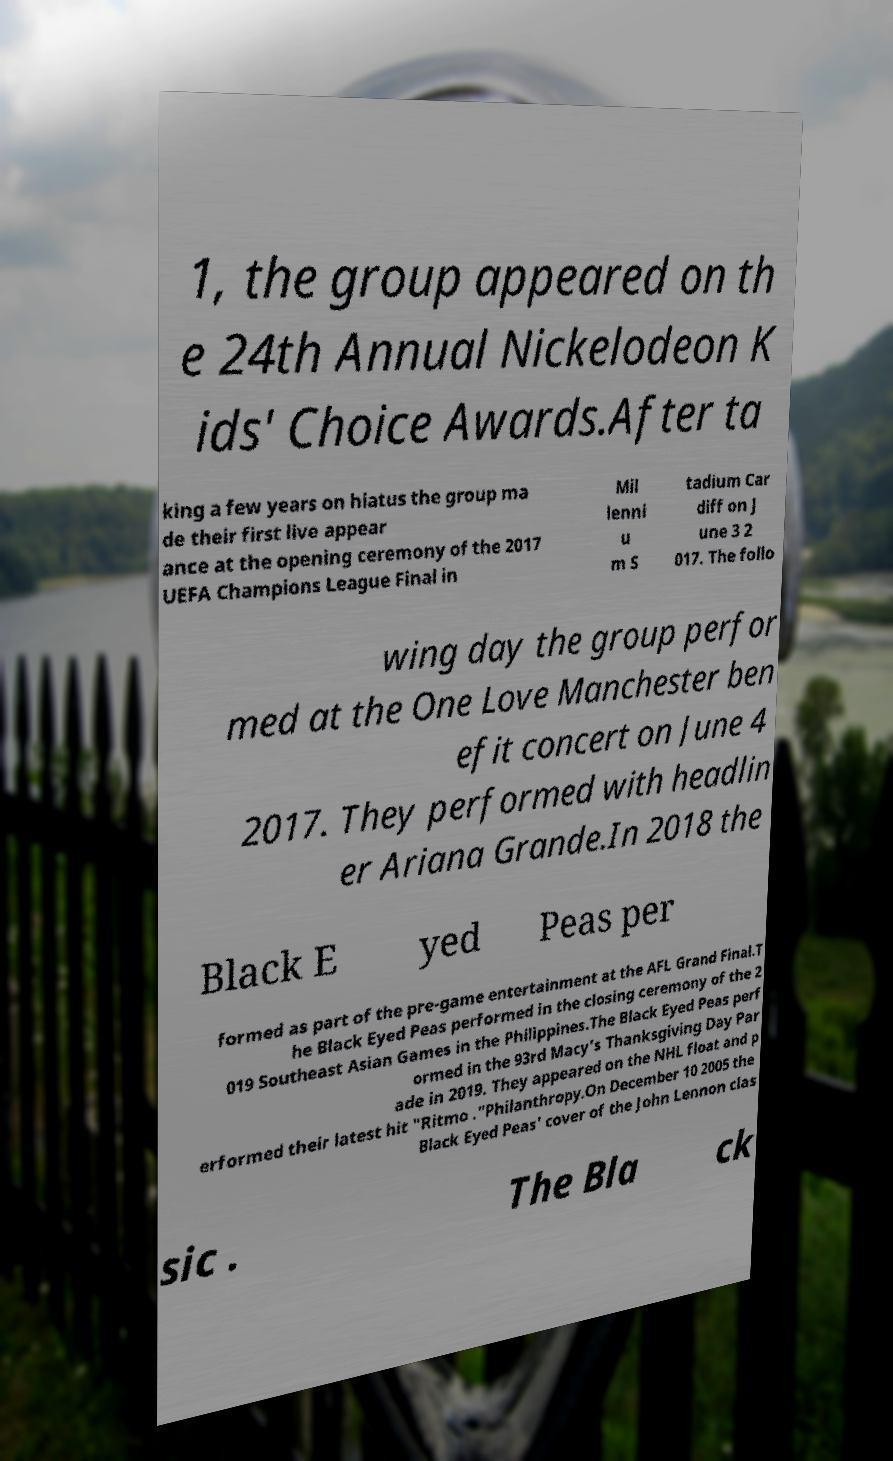Please identify and transcribe the text found in this image. 1, the group appeared on th e 24th Annual Nickelodeon K ids' Choice Awards.After ta king a few years on hiatus the group ma de their first live appear ance at the opening ceremony of the 2017 UEFA Champions League Final in Mil lenni u m S tadium Car diff on J une 3 2 017. The follo wing day the group perfor med at the One Love Manchester ben efit concert on June 4 2017. They performed with headlin er Ariana Grande.In 2018 the Black E yed Peas per formed as part of the pre-game entertainment at the AFL Grand Final.T he Black Eyed Peas performed in the closing ceremony of the 2 019 Southeast Asian Games in the Philippines.The Black Eyed Peas perf ormed in the 93rd Macy's Thanksgiving Day Par ade in 2019. They appeared on the NHL float and p erformed their latest hit "Ritmo ."Philanthropy.On December 10 2005 the Black Eyed Peas' cover of the John Lennon clas sic . The Bla ck 